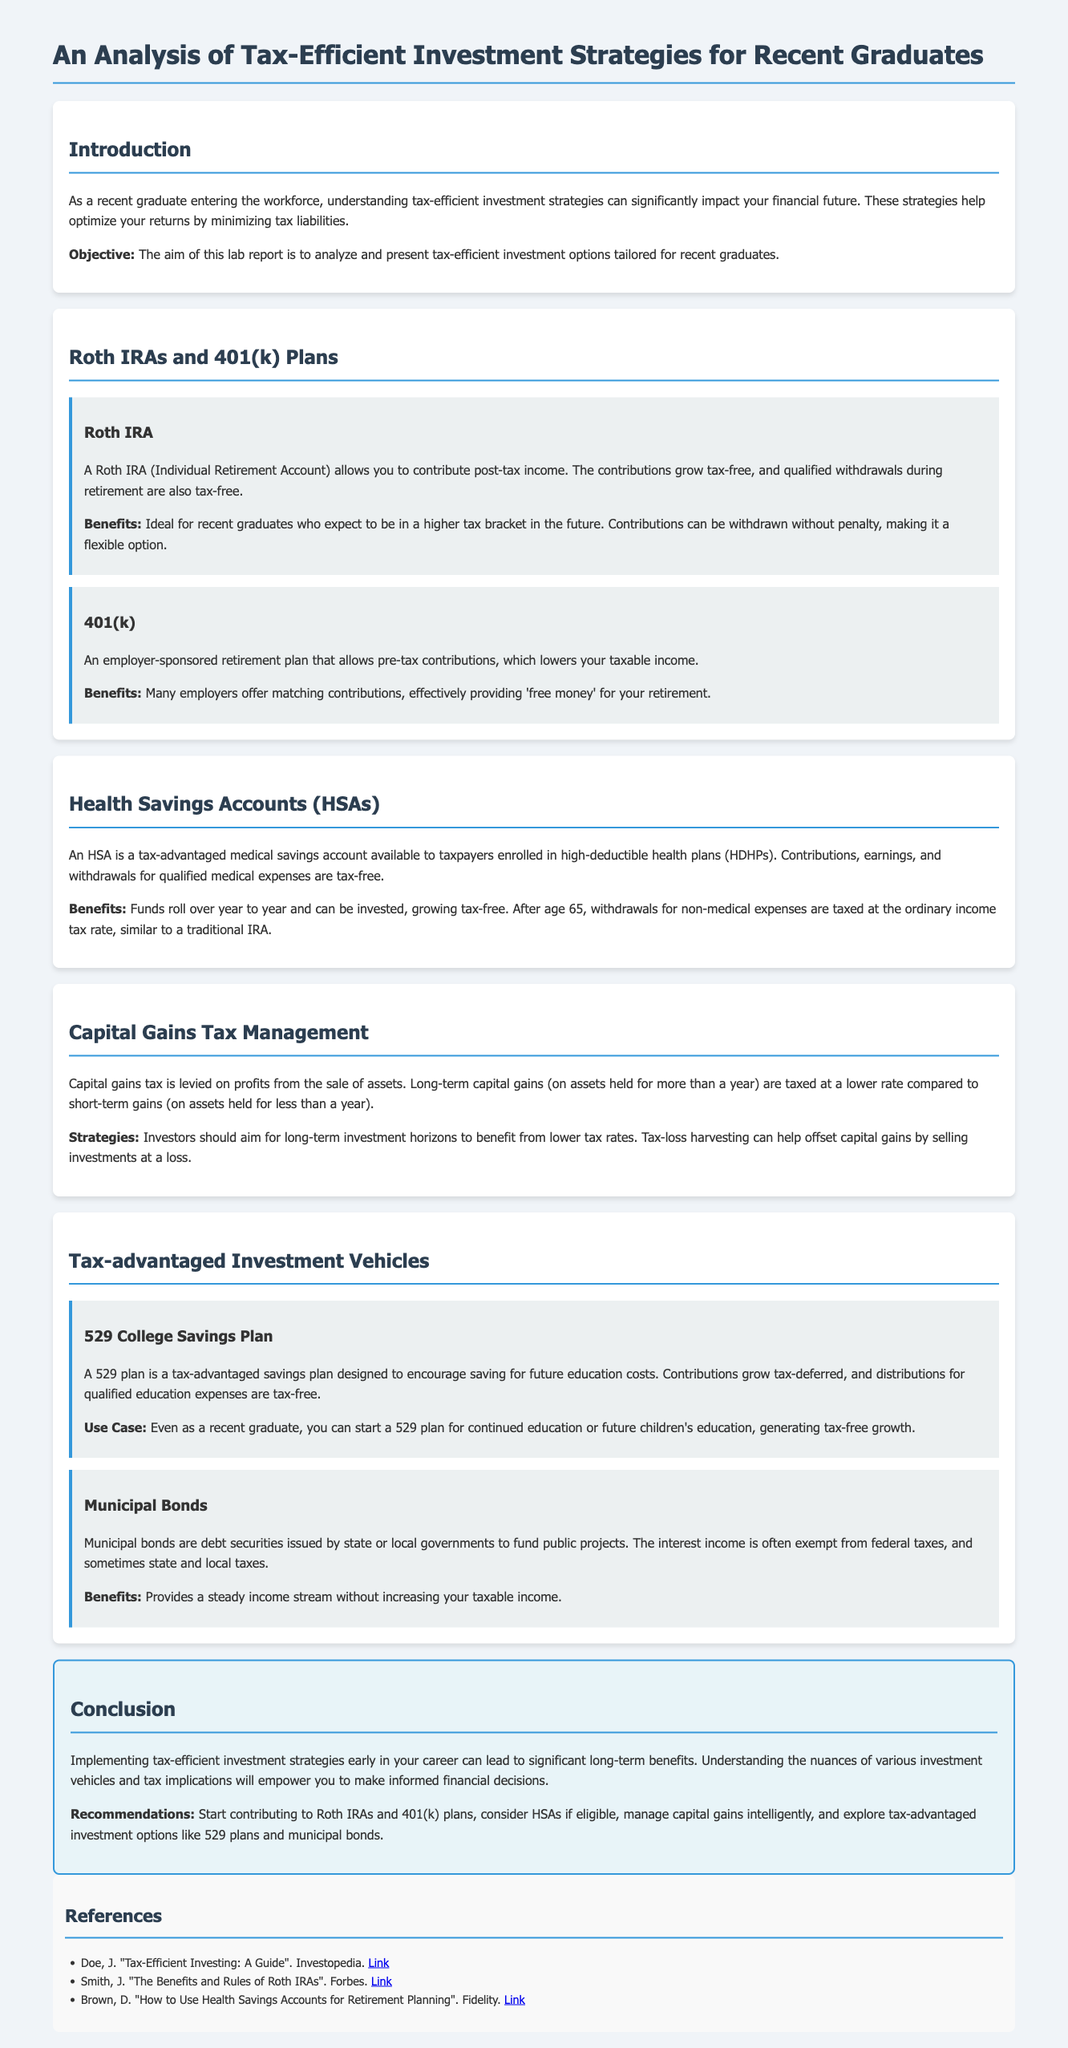What is the main objective of the lab report? The main objective of the lab report is to analyze and present tax-efficient investment options tailored for recent graduates.
Answer: Analyze and present tax-efficient investment options tailored for recent graduates What type of retirement account allows post-tax income contributions? A Roth IRA allows you to contribute post-tax income.
Answer: Roth IRA What is the tax treatment of contributions and withdrawals for HSAs? Contributions, earnings, and withdrawals for qualified medical expenses are tax-free.
Answer: Tax-free What kind of investment strategy can help offset capital gains? Tax-loss harvesting can help offset capital gains.
Answer: Tax-loss harvesting Which plan is specifically designed for future education costs? A 529 College Savings Plan is designed to encourage saving for future education costs.
Answer: 529 College Savings Plan What type of bonds provide interest income that is often exempt from federal taxes? Municipal bonds provide interest income that is often exempt from federal taxes.
Answer: Municipal bonds What is the retirement benefit of a 401(k) plan? Many employers offer matching contributions, effectively providing 'free money' for your retirement.
Answer: Free money What should recent graduates do to implement tax-efficient strategies early in their careers? Start contributing to Roth IRAs and 401(k) plans.
Answer: Contribute to Roth IRAs and 401(k) plans 